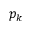<formula> <loc_0><loc_0><loc_500><loc_500>p _ { k }</formula> 